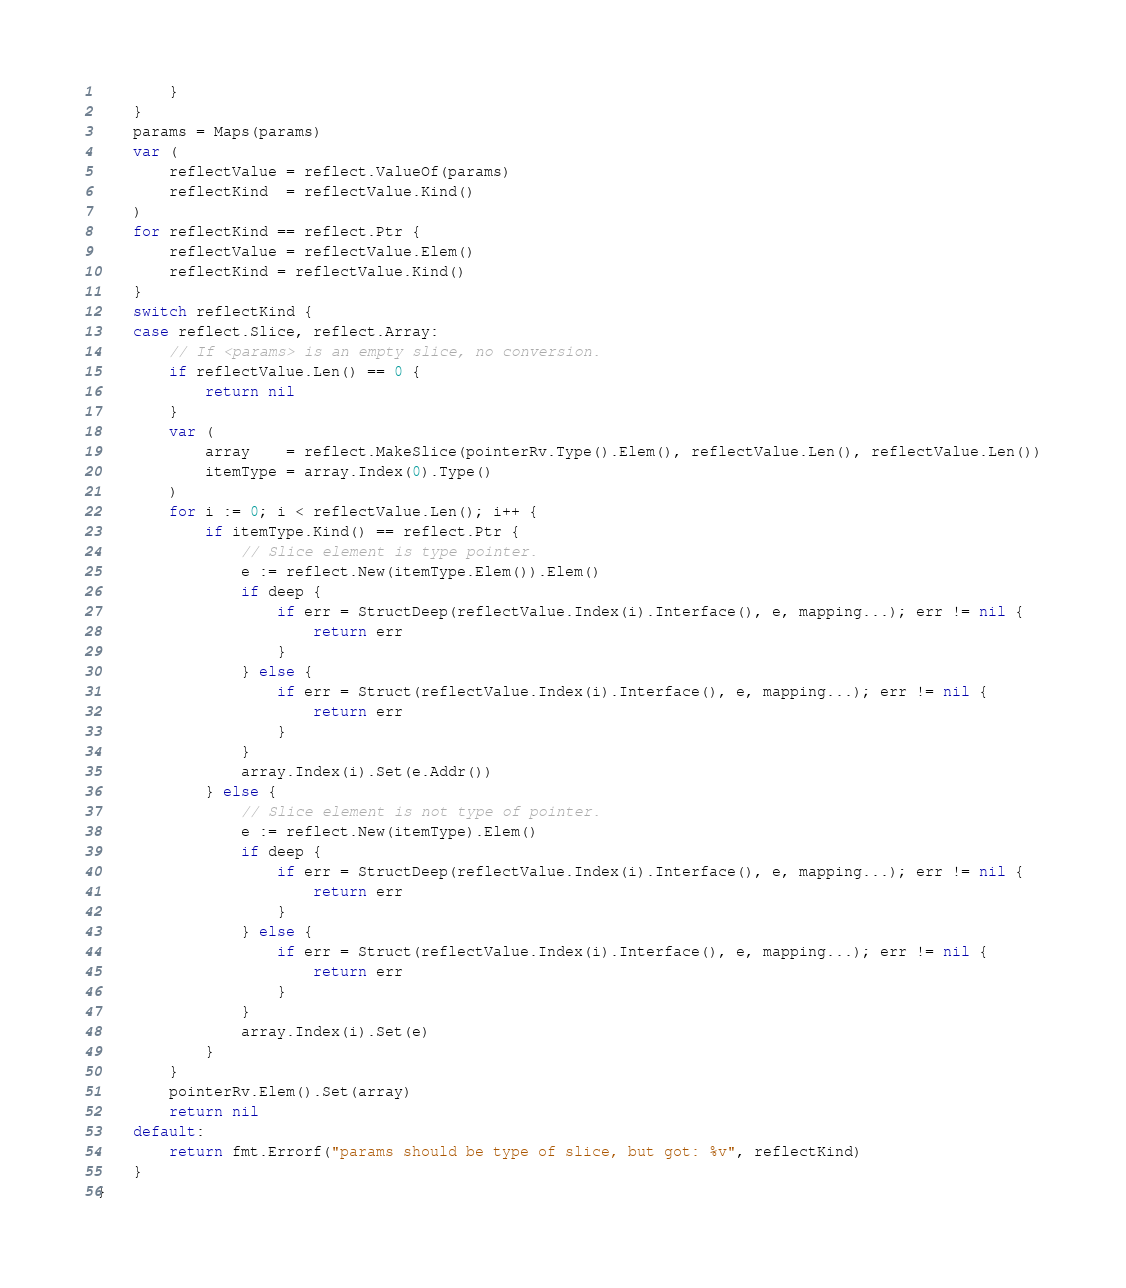<code> <loc_0><loc_0><loc_500><loc_500><_Go_>		}
	}
	params = Maps(params)
	var (
		reflectValue = reflect.ValueOf(params)
		reflectKind  = reflectValue.Kind()
	)
	for reflectKind == reflect.Ptr {
		reflectValue = reflectValue.Elem()
		reflectKind = reflectValue.Kind()
	}
	switch reflectKind {
	case reflect.Slice, reflect.Array:
		// If <params> is an empty slice, no conversion.
		if reflectValue.Len() == 0 {
			return nil
		}
		var (
			array    = reflect.MakeSlice(pointerRv.Type().Elem(), reflectValue.Len(), reflectValue.Len())
			itemType = array.Index(0).Type()
		)
		for i := 0; i < reflectValue.Len(); i++ {
			if itemType.Kind() == reflect.Ptr {
				// Slice element is type pointer.
				e := reflect.New(itemType.Elem()).Elem()
				if deep {
					if err = StructDeep(reflectValue.Index(i).Interface(), e, mapping...); err != nil {
						return err
					}
				} else {
					if err = Struct(reflectValue.Index(i).Interface(), e, mapping...); err != nil {
						return err
					}
				}
				array.Index(i).Set(e.Addr())
			} else {
				// Slice element is not type of pointer.
				e := reflect.New(itemType).Elem()
				if deep {
					if err = StructDeep(reflectValue.Index(i).Interface(), e, mapping...); err != nil {
						return err
					}
				} else {
					if err = Struct(reflectValue.Index(i).Interface(), e, mapping...); err != nil {
						return err
					}
				}
				array.Index(i).Set(e)
			}
		}
		pointerRv.Elem().Set(array)
		return nil
	default:
		return fmt.Errorf("params should be type of slice, but got: %v", reflectKind)
	}
}
</code> 